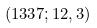Convert formula to latex. <formula><loc_0><loc_0><loc_500><loc_500>( 1 3 3 7 ; 1 2 , 3 )</formula> 